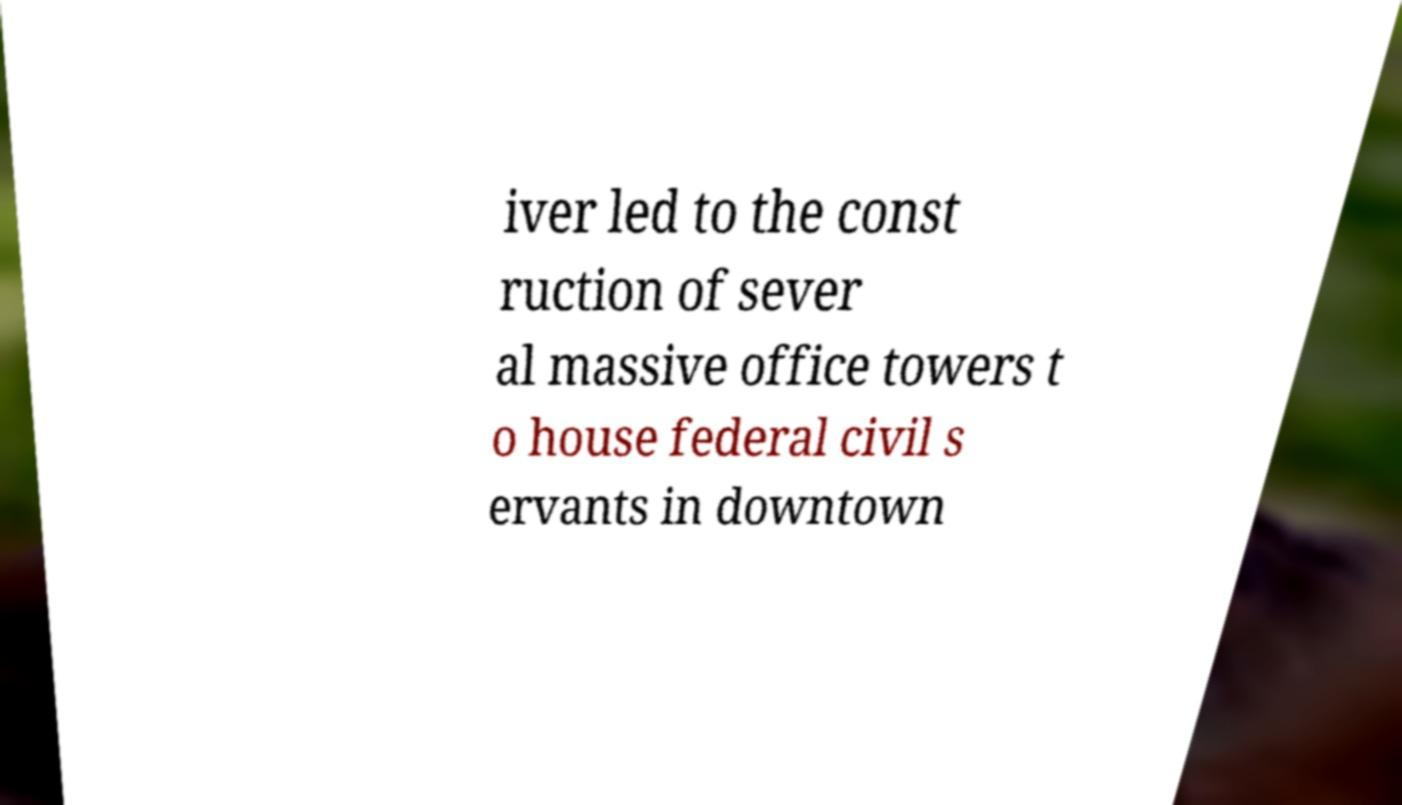Could you extract and type out the text from this image? iver led to the const ruction of sever al massive office towers t o house federal civil s ervants in downtown 